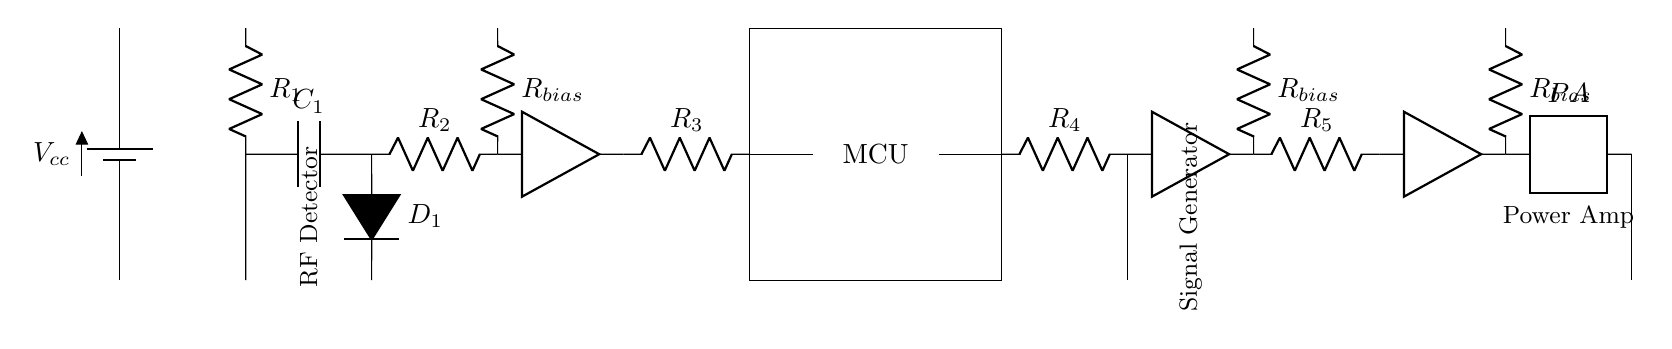What is the role of the MCU in this circuit? The microcontroller unit (MCU) processes signals from the RF detector, controls the jamming generator, and manages overall functionality.
Answer: Microcontroller unit What components are used in the RF detector section? The RF detector consists of a resistor labeled R1, a capacitor labeled C1, a diode labeled D1, and another resistor labeled R2.
Answer: R1, C1, D1, R2 What is the purpose of the jamming signal generator? The jamming signal generator produces a signal that interferes with surveillance devices, preventing them from receiving valid transmissions.
Answer: Interference How many amplifiers are present in this circuit? There are three amplifiers: one after the RF detector, one after the jamming signal generator, and one before the antenna output.
Answer: Three What might happen if R3 is too high? If R3 has too high a resistance, it can limit the current to the amplifier, potentially reducing the gain and effectiveness of the signal amplification.
Answer: Reduced amplification Which component converts the signal to RF for transmission? The component labeled "PA," which stands for Power Amplifier, converts the newly generated signals into RF for transmission through the antenna.
Answer: Power Amplifier What is the main power supply voltage denoted as? The main power supply voltage is denoted as Vcc, which is standard notation for the positive supply voltage in circuits.
Answer: Vcc 